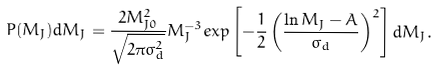<formula> <loc_0><loc_0><loc_500><loc_500>P ( M _ { J } ) d M _ { J } = \frac { 2 M _ { J 0 } ^ { 2 } } { \sqrt { 2 \pi \sigma ^ { 2 } _ { d } } } M ^ { - 3 } _ { J } e x p \left [ - \frac { 1 } { 2 } \left ( \frac { \ln M _ { J } - A } { \sigma _ { d } } \right ) ^ { 2 } \right ] d M _ { J } .</formula> 